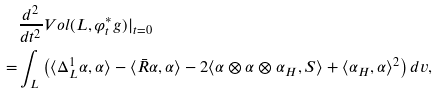Convert formula to latex. <formula><loc_0><loc_0><loc_500><loc_500>& \frac { d ^ { 2 } } { d t ^ { 2 } } V o l ( L , \varphi _ { t } ^ { \ast } g ) | _ { t = 0 } \\ = & \int _ { L } \left ( \langle \Delta ^ { 1 } _ { L } \alpha , \alpha \rangle - \langle \bar { R } \alpha , \alpha \rangle - 2 \langle \alpha \otimes \alpha \otimes \alpha _ { H } , S \rangle + \langle \alpha _ { H } , \alpha \rangle ^ { 2 } \right ) d v ,</formula> 